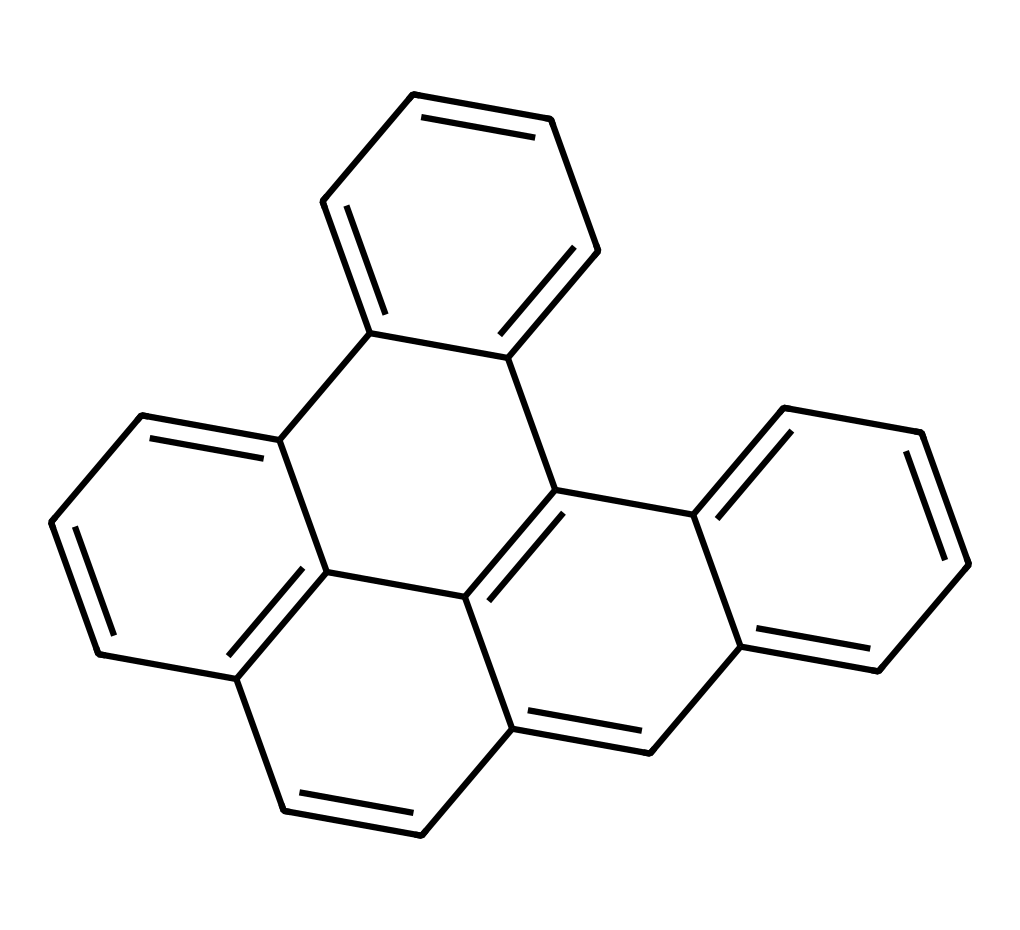What is the total number of carbon atoms in this structure? By examining the SMILES representation and counting the 'c' characters that denote carbon atoms in aromatic rings, we find there are 16 occurrences of 'c'. This indicates there are 16 carbon atoms in total.
Answer: 16 What type of bonding is primarily present in this chemical? The structure consists mainly of carbon-carbon double bonds, typical of aromatic compounds, and it features a network of conjugated pi electrons that contribute to resonance, indicating strong covalent bonding throughout the molecule.
Answer: covalent How many benzene rings are present in the chemical structure? The chemical structure can be analyzed by identifying distinct aromatic rings. Upon inspection, I recognize 5 benzene rings contributing to the overall complexity of the structure.
Answer: 5 What property allows graphene quantum dots to be effective in energy storage? The unique electronic and optical properties of graphene quantum dots, such as high conductivity and large surface area for charge storage, enhance their capacity for energy storage in renewable systems.
Answer: high conductivity What are the potential applications of the structure in renewable power systems? This chemical, being a type of quantum dot, can be used in applications such as solar cells and supercapacitors, significantly improving energy conversion and storage efficiencies in renewable power systems.
Answer: solar cells, supercapacitors What characteristic feature of the structure enhances its stability? The presence of multiple interconnected aromatic rings contributes to the stability of the molecule by allowing delocalization of electrons, which reinforces structural integrity and reduces reactivity.
Answer: delocalization of electrons 